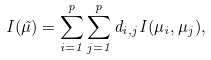Convert formula to latex. <formula><loc_0><loc_0><loc_500><loc_500>I ( \vec { \mu } ) = \sum _ { i = 1 } ^ { p } \sum _ { j = 1 } ^ { p } d _ { i , j } I ( \mu _ { i } , \mu _ { j } ) ,</formula> 